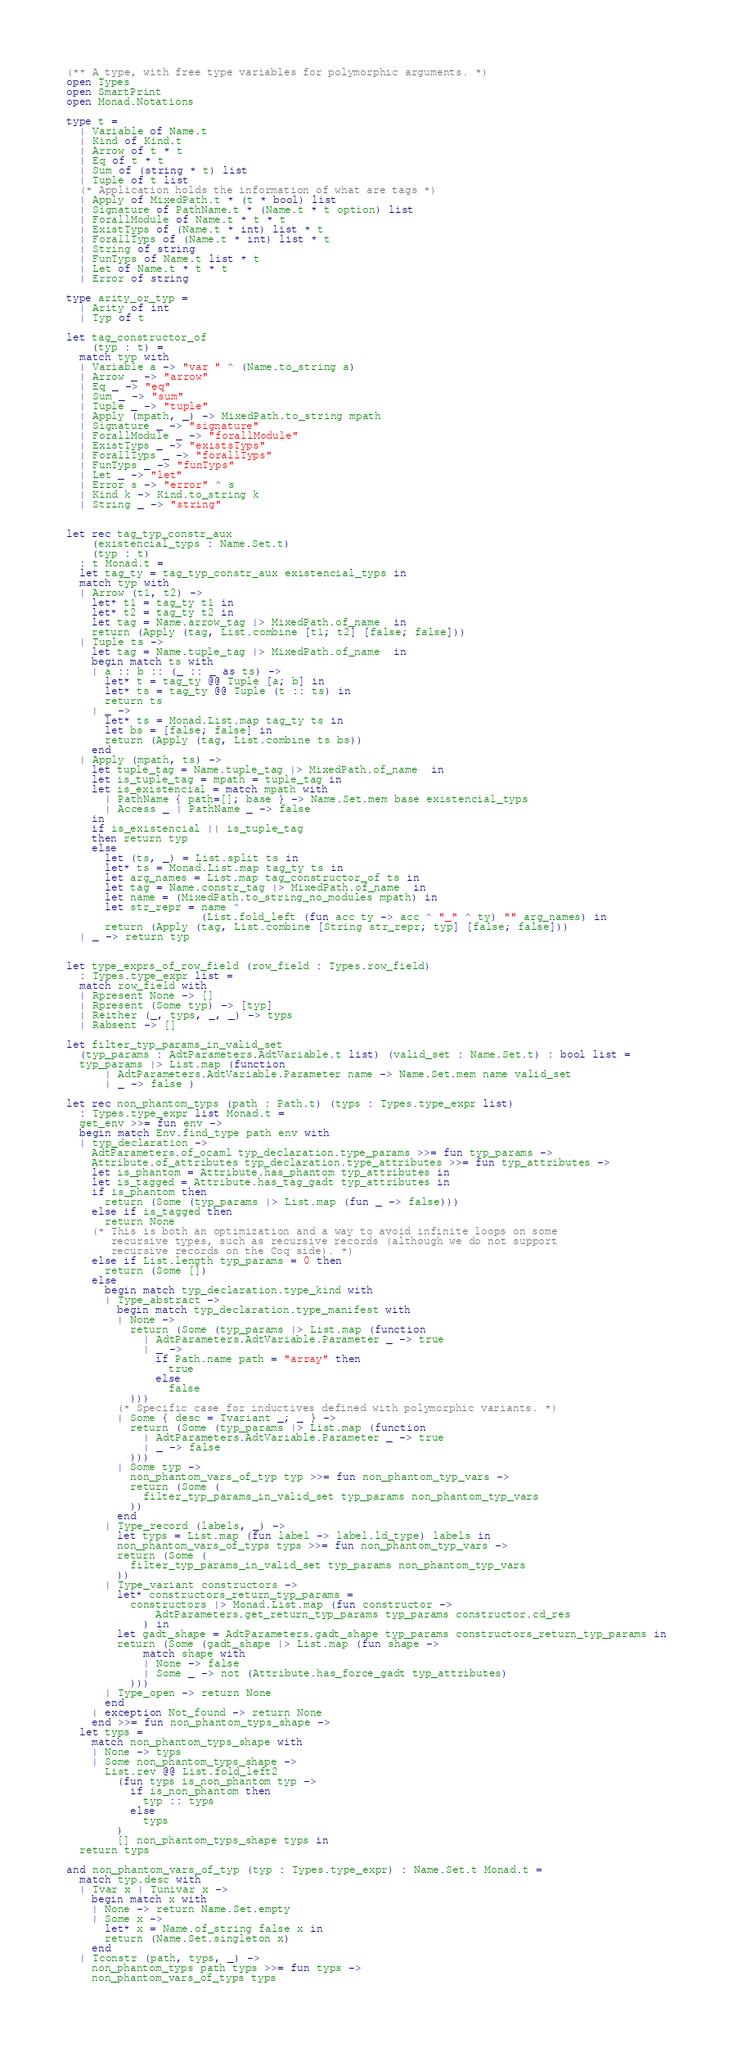Convert code to text. <code><loc_0><loc_0><loc_500><loc_500><_OCaml_>(** A type, with free type variables for polymorphic arguments. *)
open Types
open SmartPrint
open Monad.Notations

type t =
  | Variable of Name.t
  | Kind of Kind.t
  | Arrow of t * t
  | Eq of t * t
  | Sum of (string * t) list
  | Tuple of t list
  (* Application holds the information of what are tags *)
  | Apply of MixedPath.t * (t * bool) list
  | Signature of PathName.t * (Name.t * t option) list
  | ForallModule of Name.t * t * t
  | ExistTyps of (Name.t * int) list * t
  | ForallTyps of (Name.t * int) list * t
  | String of string
  | FunTyps of Name.t list * t
  | Let of Name.t * t * t
  | Error of string

type arity_or_typ =
  | Arity of int
  | Typ of t

let tag_constructor_of
    (typ : t) =
  match typ with
  | Variable a -> "var " ^ (Name.to_string a)
  | Arrow _ -> "arrow"
  | Eq _ -> "eq"
  | Sum _ -> "sum"
  | Tuple _ -> "tuple"
  | Apply (mpath, _) -> MixedPath.to_string mpath
  | Signature _ -> "signature"
  | ForallModule _ -> "forallModule"
  | ExistTyps _ -> "existsTyps"
  | ForallTyps _ -> "forallTyps"
  | FunTyps _ -> "funTyps"
  | Let _ -> "let"
  | Error s -> "error" ^ s
  | Kind k -> Kind.to_string k
  | String _ -> "string"


let rec tag_typ_constr_aux
    (existencial_typs : Name.Set.t)
    (typ : t)
  : t Monad.t =
  let tag_ty = tag_typ_constr_aux existencial_typs in
  match typ with
  | Arrow (t1, t2) ->
    let* t1 = tag_ty t1 in
    let* t2 = tag_ty t2 in
    let tag = Name.arrow_tag |> MixedPath.of_name  in
    return (Apply (tag, List.combine [t1; t2] [false; false]))
  | Tuple ts ->
    let tag = Name.tuple_tag |> MixedPath.of_name  in
    begin match ts with
    | a :: b :: (_ :: _ as ts) ->
      let* t = tag_ty @@ Tuple [a; b] in
      let* ts = tag_ty @@ Tuple (t :: ts) in
      return ts
    | _ ->
      let* ts = Monad.List.map tag_ty ts in
      let bs = [false; false] in
      return (Apply (tag, List.combine ts bs))
    end
  | Apply (mpath, ts) ->
    let tuple_tag = Name.tuple_tag |> MixedPath.of_name  in
    let is_tuple_tag = mpath = tuple_tag in
    let is_existencial = match mpath with
      | PathName { path=[]; base } -> Name.Set.mem base existencial_typs
      | Access _ | PathName _ -> false
    in
    if is_existencial || is_tuple_tag
    then return typ
    else
      let (ts, _) = List.split ts in
      let* ts = Monad.List.map tag_ty ts in
      let arg_names = List.map tag_constructor_of ts in
      let tag = Name.constr_tag |> MixedPath.of_name  in
      let name = (MixedPath.to_string_no_modules mpath) in
      let str_repr = name ^
                     (List.fold_left (fun acc ty -> acc ^ "_" ^ ty) "" arg_names) in
      return (Apply (tag, List.combine [String str_repr; typ] [false; false]))
  | _ -> return typ


let type_exprs_of_row_field (row_field : Types.row_field)
  : Types.type_expr list =
  match row_field with
  | Rpresent None -> []
  | Rpresent (Some typ) -> [typ]
  | Reither (_, typs, _, _) -> typs
  | Rabsent -> []

let filter_typ_params_in_valid_set
  (typ_params : AdtParameters.AdtVariable.t list) (valid_set : Name.Set.t) : bool list =
  typ_params |> List.map (function
      | AdtParameters.AdtVariable.Parameter name -> Name.Set.mem name valid_set
      | _ -> false )

let rec non_phantom_typs (path : Path.t) (typs : Types.type_expr list)
  : Types.type_expr list Monad.t =
  get_env >>= fun env ->
  begin match Env.find_type path env with
  | typ_declaration ->
    AdtParameters.of_ocaml typ_declaration.type_params >>= fun typ_params ->
    Attribute.of_attributes typ_declaration.type_attributes >>= fun typ_attributes ->
    let is_phantom = Attribute.has_phantom typ_attributes in
    let is_tagged = Attribute.has_tag_gadt typ_attributes in
    if is_phantom then
      return (Some (typ_params |> List.map (fun _ -> false)))
    else if is_tagged then
      return None
    (* This is both an optimization and a way to avoid infinite loops on some
       recursive types, such as recursive records (although we do not support
       recursive records on the Coq side). *)
    else if List.length typ_params = 0 then
      return (Some [])
    else
      begin match typ_declaration.type_kind with
      | Type_abstract ->
        begin match typ_declaration.type_manifest with
        | None ->
          return (Some (typ_params |> List.map (function
            | AdtParameters.AdtVariable.Parameter _ -> true
            | _ ->
              if Path.name path = "array" then
                true
              else
                false
          )))
        (* Specific case for inductives defined with polymorphic variants. *)
        | Some { desc = Tvariant _; _ } ->
          return (Some (typ_params |> List.map (function
            | AdtParameters.AdtVariable.Parameter _ -> true
            | _ -> false
          )))
        | Some typ ->
          non_phantom_vars_of_typ typ >>= fun non_phantom_typ_vars ->
          return (Some (
            filter_typ_params_in_valid_set typ_params non_phantom_typ_vars
          ))
        end
      | Type_record (labels, _) ->
        let typs = List.map (fun label -> label.ld_type) labels in
        non_phantom_vars_of_typs typs >>= fun non_phantom_typ_vars ->
        return (Some (
          filter_typ_params_in_valid_set typ_params non_phantom_typ_vars
        ))
      | Type_variant constructors ->
        let* constructors_return_typ_params =
          constructors |> Monad.List.map (fun constructor ->
              AdtParameters.get_return_typ_params typ_params constructor.cd_res
            ) in
        let gadt_shape = AdtParameters.gadt_shape typ_params constructors_return_typ_params in
        return (Some (gadt_shape |> List.map (fun shape ->
            match shape with
            | None -> false
            | Some _ -> not (Attribute.has_force_gadt typ_attributes)
          )))
      | Type_open -> return None
      end
    | exception Not_found -> return None
    end >>= fun non_phantom_typs_shape ->
  let typs =
    match non_phantom_typs_shape with
    | None -> typs
    | Some non_phantom_typs_shape ->
      List.rev @@ List.fold_left2
        (fun typs is_non_phantom typ ->
          if is_non_phantom then
            typ :: typs
          else
            typs
        )
        [] non_phantom_typs_shape typs in
  return typs

and non_phantom_vars_of_typ (typ : Types.type_expr) : Name.Set.t Monad.t =
  match typ.desc with
  | Tvar x | Tunivar x ->
    begin match x with
    | None -> return Name.Set.empty
    | Some x ->
      let* x = Name.of_string false x in
      return (Name.Set.singleton x)
    end
  | Tconstr (path, typs, _) ->
    non_phantom_typs path typs >>= fun typs ->
    non_phantom_vars_of_typs typs</code> 